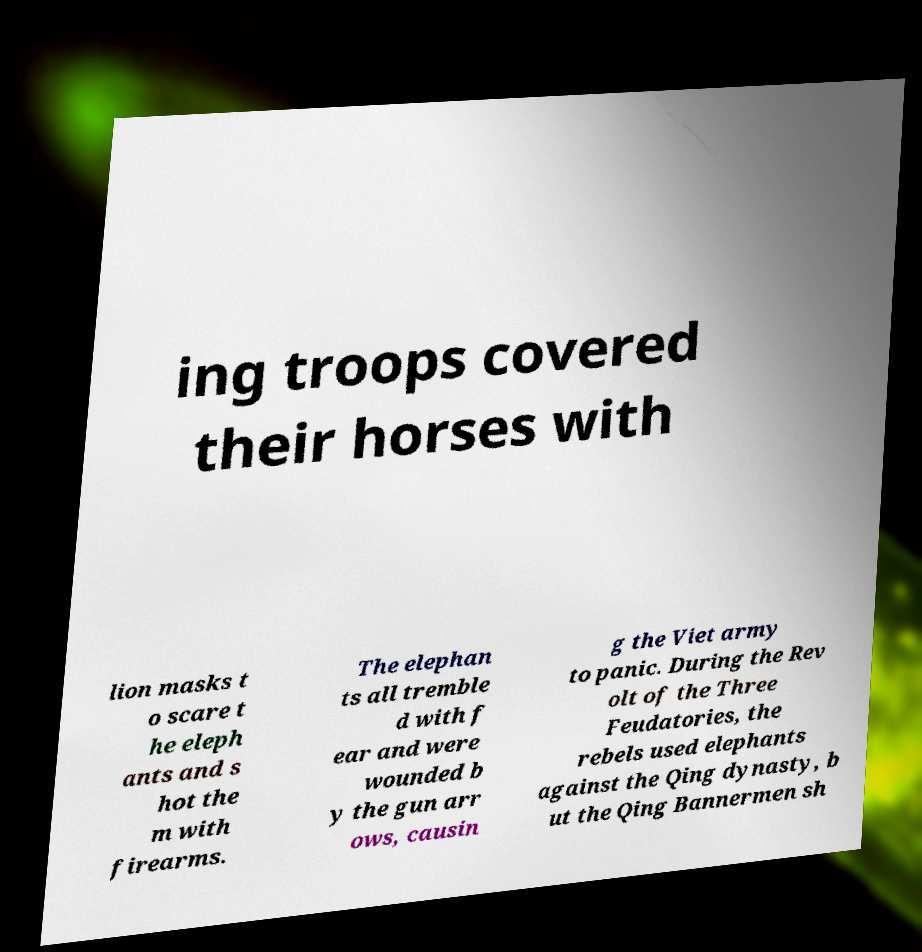Please identify and transcribe the text found in this image. ing troops covered their horses with lion masks t o scare t he eleph ants and s hot the m with firearms. The elephan ts all tremble d with f ear and were wounded b y the gun arr ows, causin g the Viet army to panic. During the Rev olt of the Three Feudatories, the rebels used elephants against the Qing dynasty, b ut the Qing Bannermen sh 